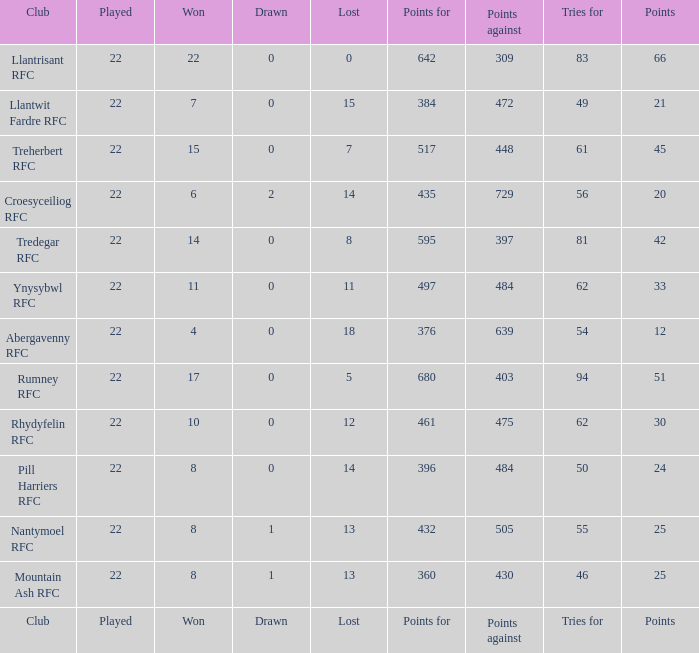For teams that won exactly 15, how many points were scored? 45.0. Give me the full table as a dictionary. {'header': ['Club', 'Played', 'Won', 'Drawn', 'Lost', 'Points for', 'Points against', 'Tries for', 'Points'], 'rows': [['Llantrisant RFC', '22', '22', '0', '0', '642', '309', '83', '66'], ['Llantwit Fardre RFC', '22', '7', '0', '15', '384', '472', '49', '21'], ['Treherbert RFC', '22', '15', '0', '7', '517', '448', '61', '45'], ['Croesyceiliog RFC', '22', '6', '2', '14', '435', '729', '56', '20'], ['Tredegar RFC', '22', '14', '0', '8', '595', '397', '81', '42'], ['Ynysybwl RFC', '22', '11', '0', '11', '497', '484', '62', '33'], ['Abergavenny RFC', '22', '4', '0', '18', '376', '639', '54', '12'], ['Rumney RFC', '22', '17', '0', '5', '680', '403', '94', '51'], ['Rhydyfelin RFC', '22', '10', '0', '12', '461', '475', '62', '30'], ['Pill Harriers RFC', '22', '8', '0', '14', '396', '484', '50', '24'], ['Nantymoel RFC', '22', '8', '1', '13', '432', '505', '55', '25'], ['Mountain Ash RFC', '22', '8', '1', '13', '360', '430', '46', '25'], ['Club', 'Played', 'Won', 'Drawn', 'Lost', 'Points for', 'Points against', 'Tries for', 'Points']]} 